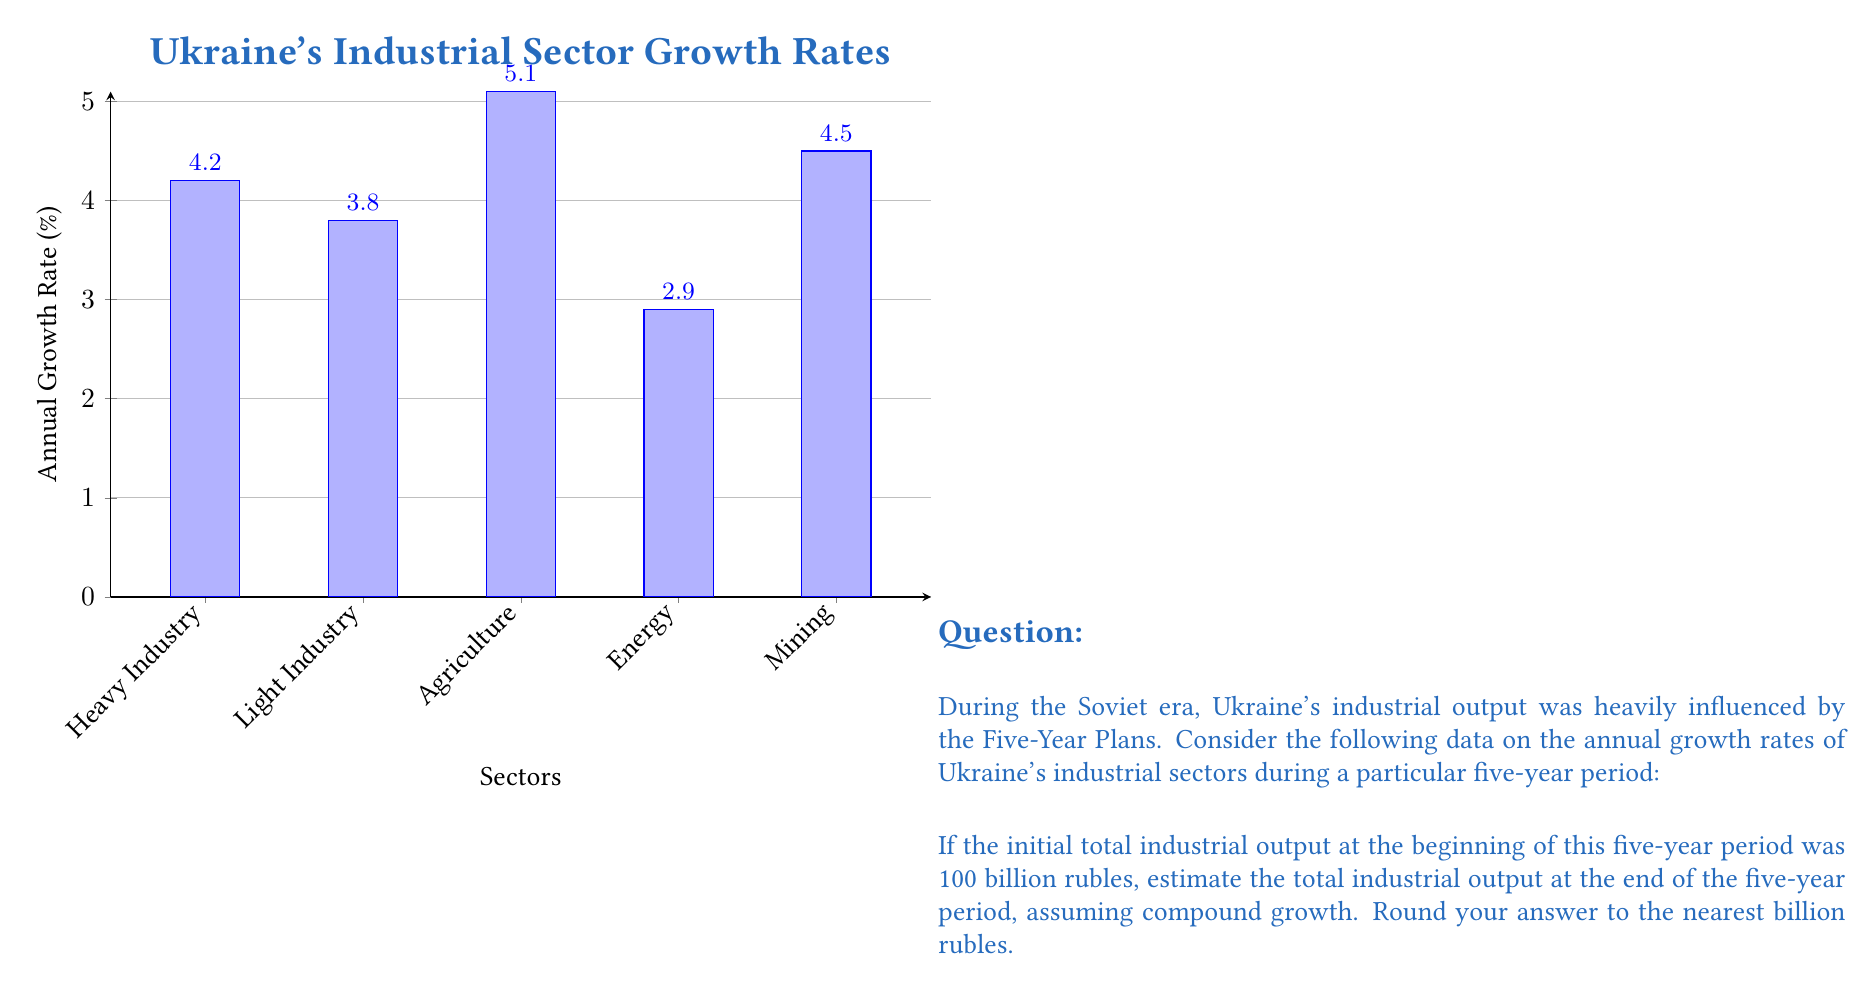What is the answer to this math problem? To solve this problem, we need to follow these steps:

1) Calculate the average annual growth rate across all sectors:
   $\frac{4.2\% + 3.8\% + 5.1\% + 2.9\% + 4.5\%}{5} = 4.1\%$

2) Convert the percentage to a decimal: $4.1\% = 0.041$

3) Use the compound growth formula:
   $A = P(1+r)^n$
   Where:
   $A$ = Final amount
   $P$ = Initial principal balance (100 billion rubles)
   $r$ = Annual interest rate (0.041)
   $n$ = Number of years (5)

4) Plug in the values:
   $A = 100(1+0.041)^5$

5) Calculate:
   $A = 100 * 1.221611$ (using a calculator)
   $A = 122.1611$ billion rubles

6) Round to the nearest billion:
   122 billion rubles
Answer: 122 billion rubles 